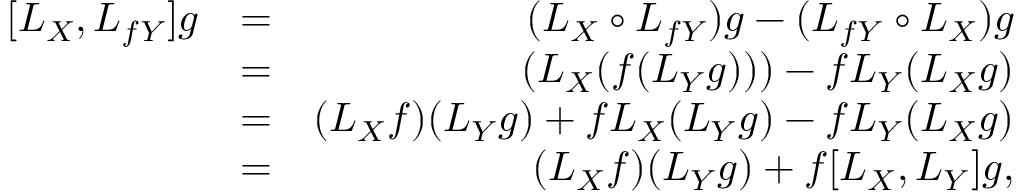<formula> <loc_0><loc_0><loc_500><loc_500>\begin{array} { r l r } { [ L _ { X } , L _ { f Y } ] g } & { = } & { ( L _ { X } \circ L _ { f Y } ) g - ( L _ { f Y } \circ L _ { X } ) g } \\ & { = } & { ( L _ { X } ( f ( L _ { Y } g ) ) ) - f L _ { Y } ( L _ { X } g ) } \\ & { = } & { ( L _ { X } f ) ( L _ { Y } g ) + f L _ { X } ( L _ { Y } g ) - f L _ { Y } ( L _ { X } g ) } \\ & { = } & { ( L _ { X } f ) ( L _ { Y } g ) + f [ L _ { X } , L _ { Y } ] g , } \end{array}</formula> 